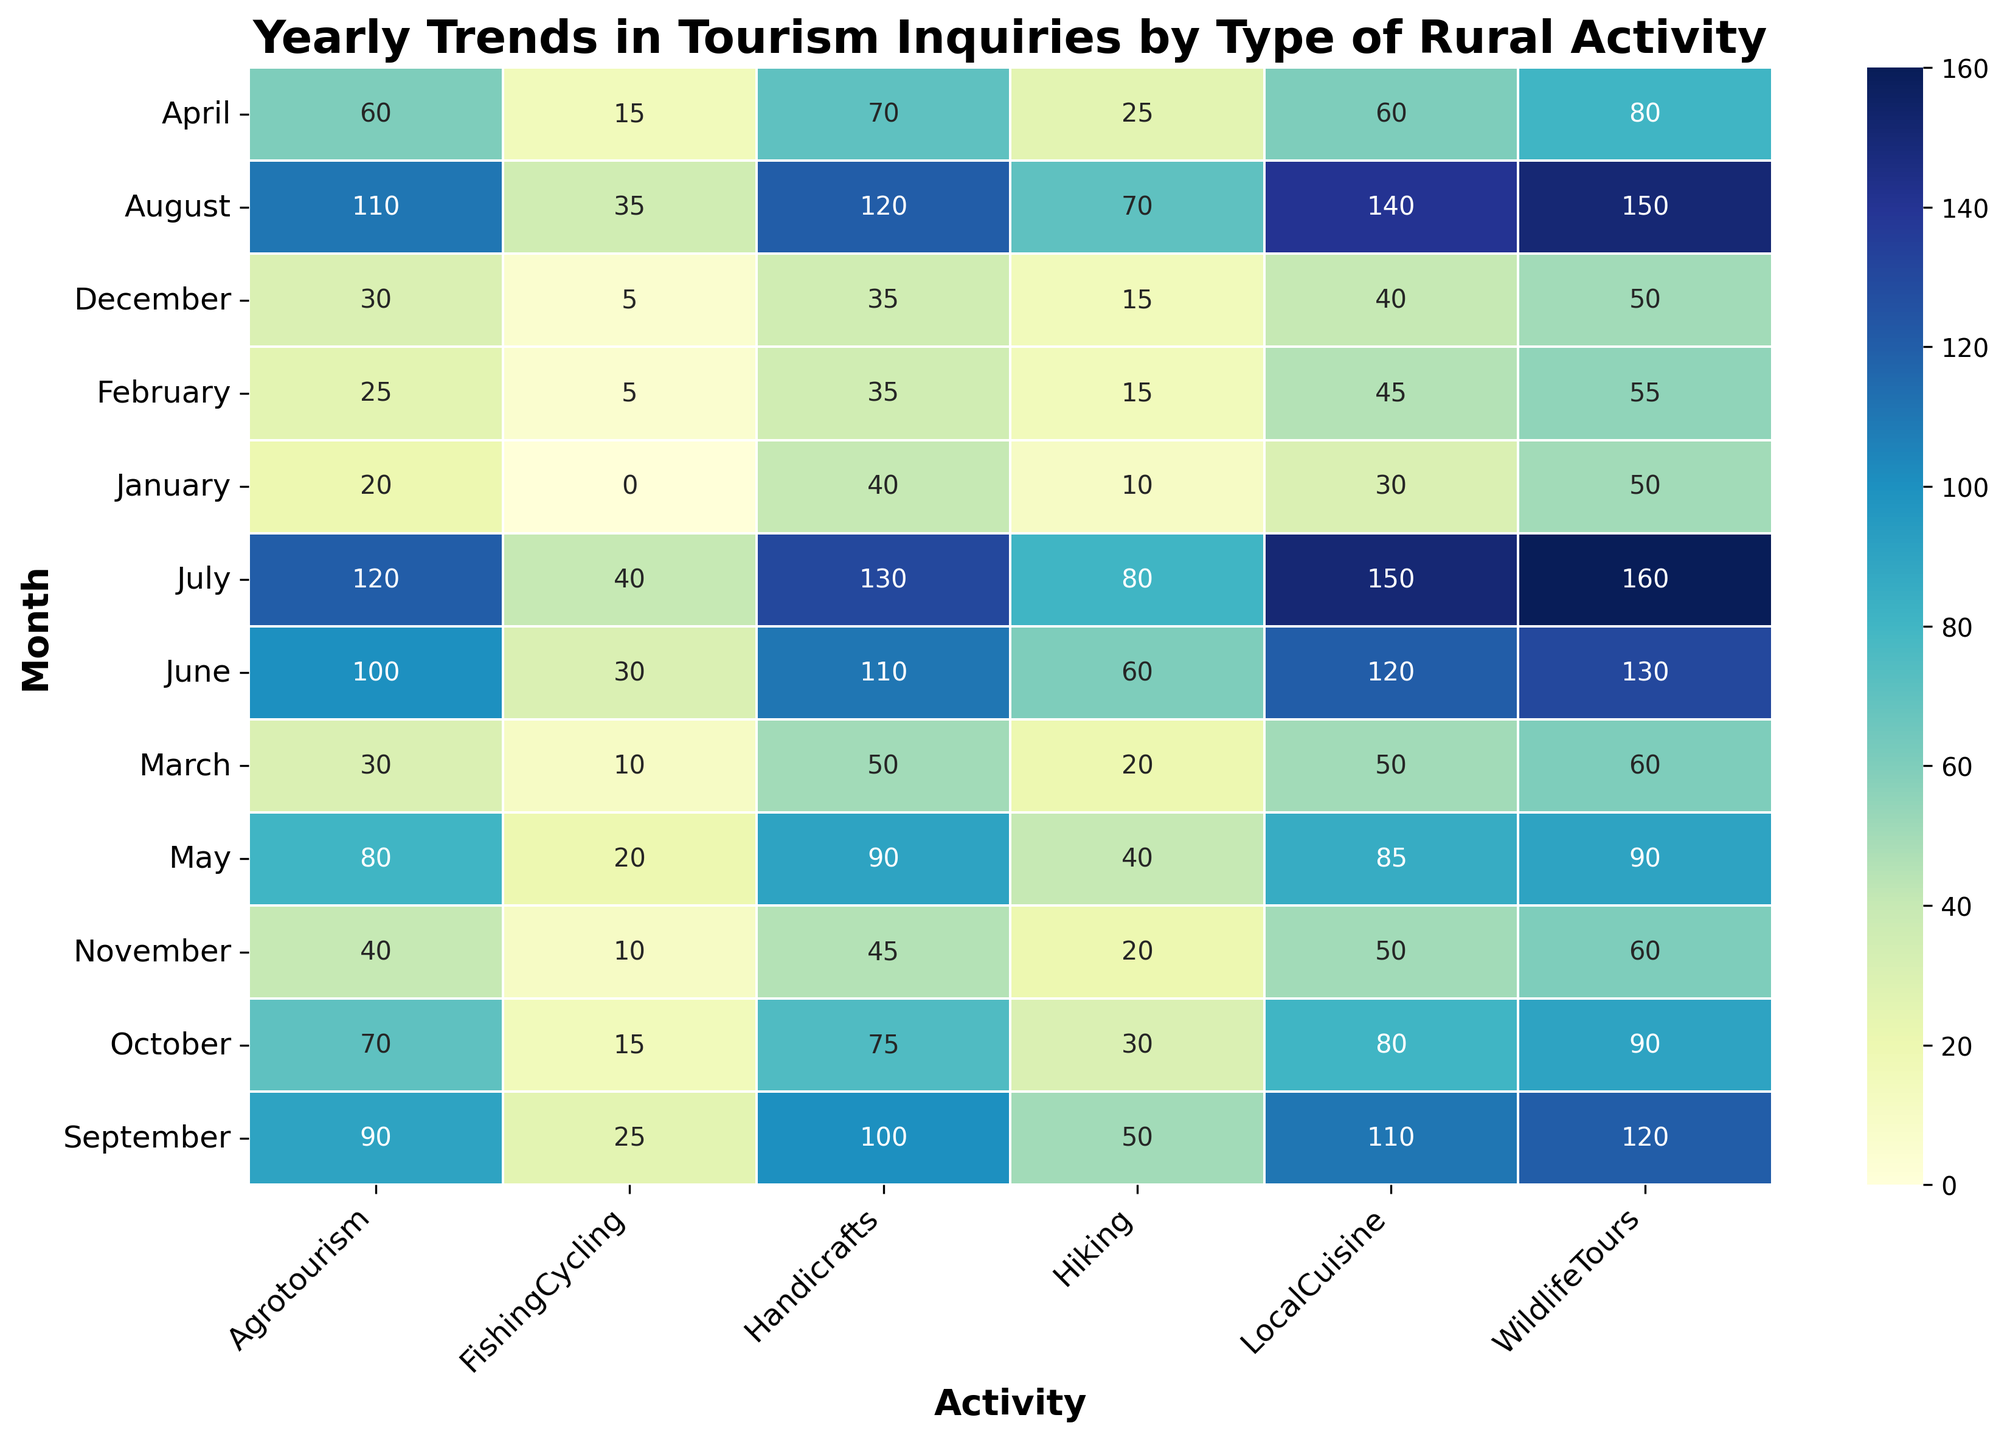What's the month with the highest inquiries for Hiking? First, identify the row for each month labeled on the y-axis. Next, find the column labeled “Hiking.” Look for the cell with the highest number in that column. The highest number for "Hiking" is 80, which is in the row labeled “July.”
Answer: July How many inquiries are there for Agrotourism in the first quarter (January, February, March) of the year? Find the "Agrotourism" column and add the numbers for January, February, and March: 20 (January) + 25 (February) + 30 (March). The sum is 20 + 25 + 30 = 75.
Answer: 75 Which activity shows the highest number of inquiries in August, and what is that number? Locate the August row and find the highest number across all the columns within that row. The highest number is 150, which is for "WildlifeTours."
Answer: WildlifeTours, 150 What is the difference in the number of inquiries for Handicrafts between the peak month and the lowest month? Identify the highest and lowest inquiries for Handicrafts by inspecting the "Handicrafts" column. The highest is 130 (July) and the lowest is 35 (February and December). The difference is 130 - 35 = 95.
Answer: 95 Which month has an equal number of inquiries for both LocalCuisine and WildlifeTours, and what is that number? Look for cells in the "LocalCuisine" and "WildlifeTours" columns that have the same number in any row. In April, both columns have the number 80.
Answer: April, 80 Compare the total inquiries for Agrotourism and Handicrafts in the second half of the year (July to December). Which one has more inquiries and by how much? Sum the inquiries for "Agrotourism" from July to December: 120 + 110 + 90 + 70 + 40 + 30 = 460. Sum the "Handicrafts" from July to December: 130 + 120 + 100 + 75 + 45 + 35 = 505. Handicrafts have more inquiries. The difference is 505 - 460 = 45.
Answer: Handicrafts, 45 What's the average number of inquiries for LocalCuisine in October and November? Find the "LocalCuisine" column and note the values for October and November: 80 (October) and 50 (November). Calculate the average: (80 + 50) / 2 = 65.
Answer: 65 Which activity has the most inquiries in June and how many inquiries are there? Identify the maximum value in the row corresponding to June from all the columns, which is 130 found in the “WildlifeTours” column.
Answer: WildlifeTours, 130 Which month has the least inquiries for FishingCycling and how many are there? Look at the “FishingCycling” column to find the lowest number. The lowest is 0 in January.
Answer: January, 0 